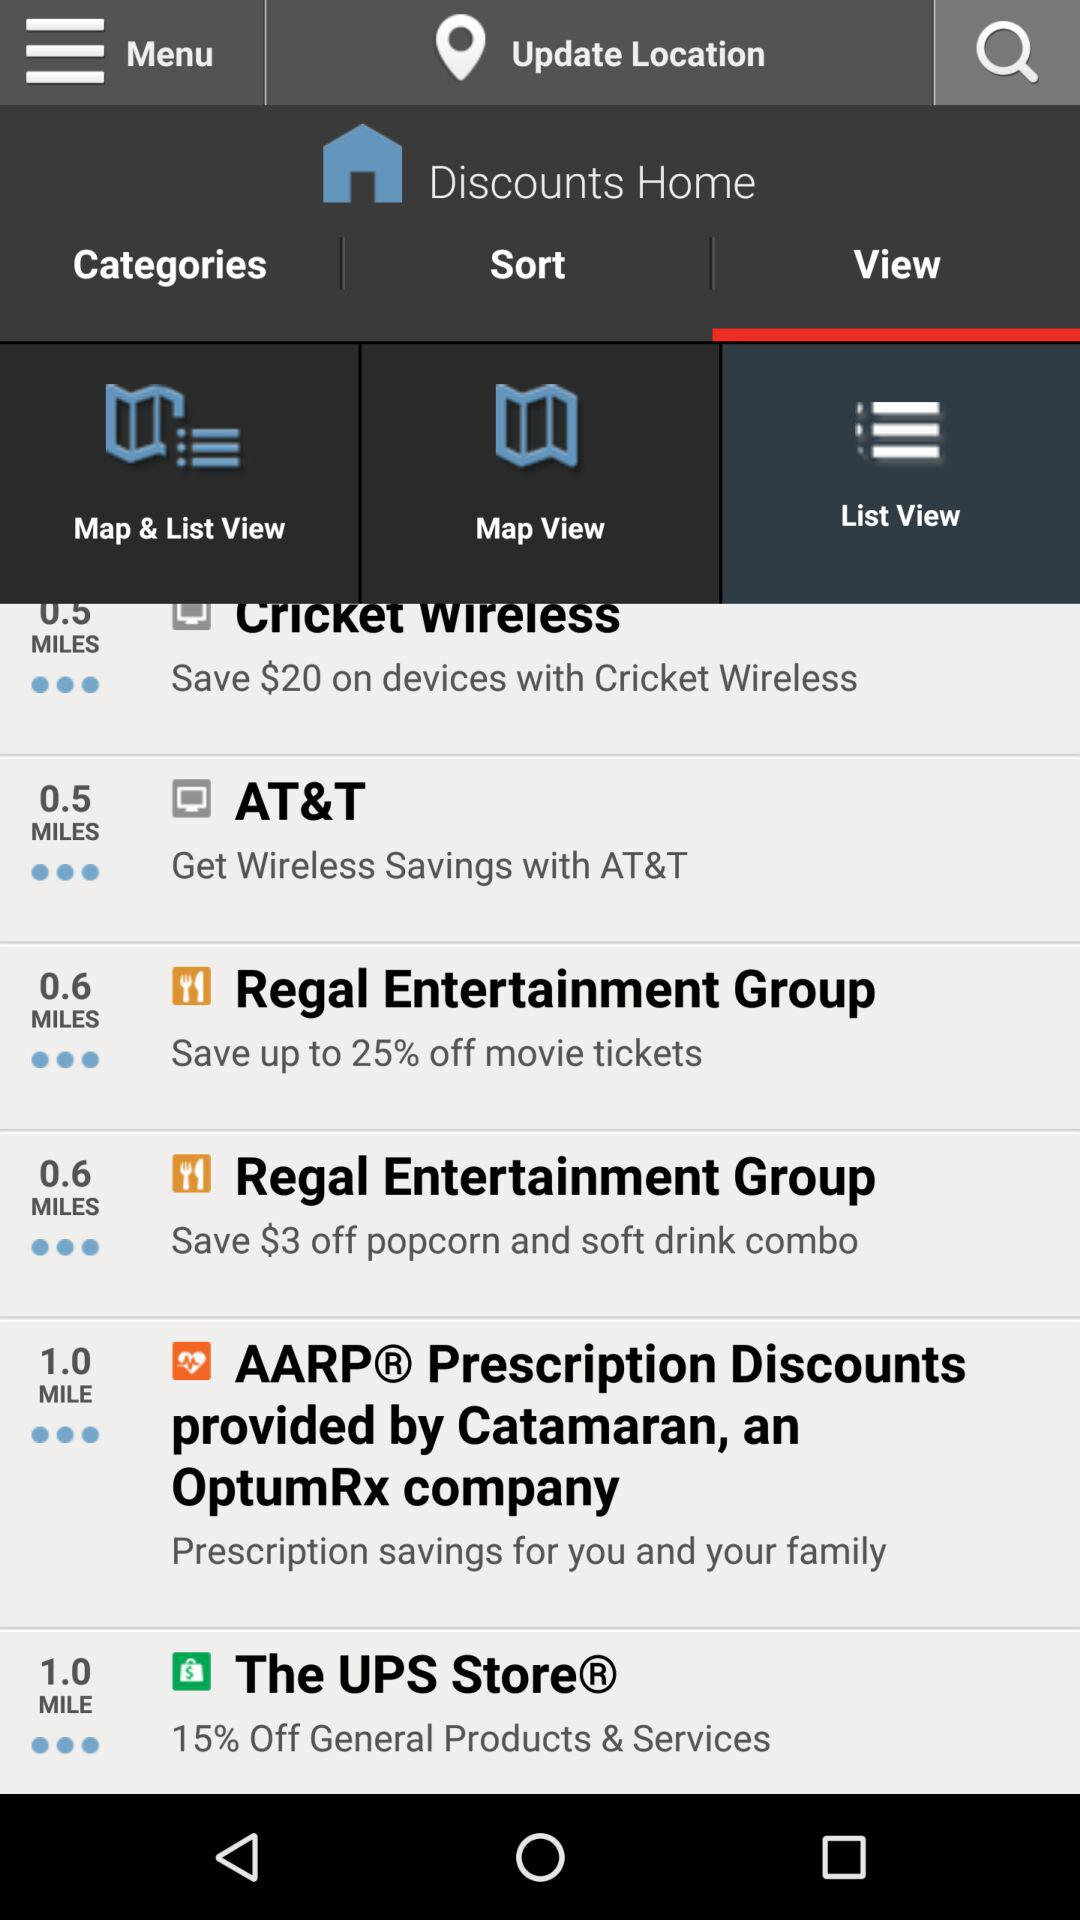What is the distance to "AT&T"? The distance to "AT&T" is 0.5 miles. 